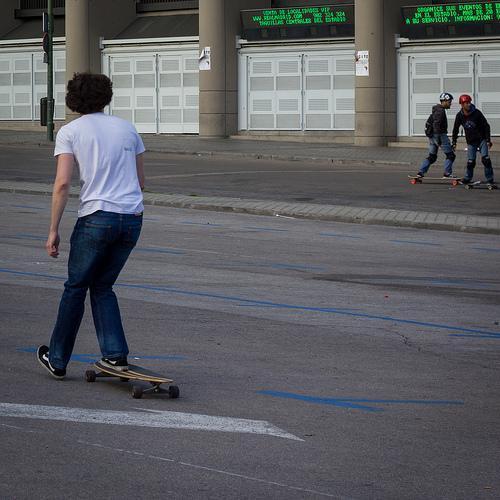How many people are shown?
Give a very brief answer. 3. 